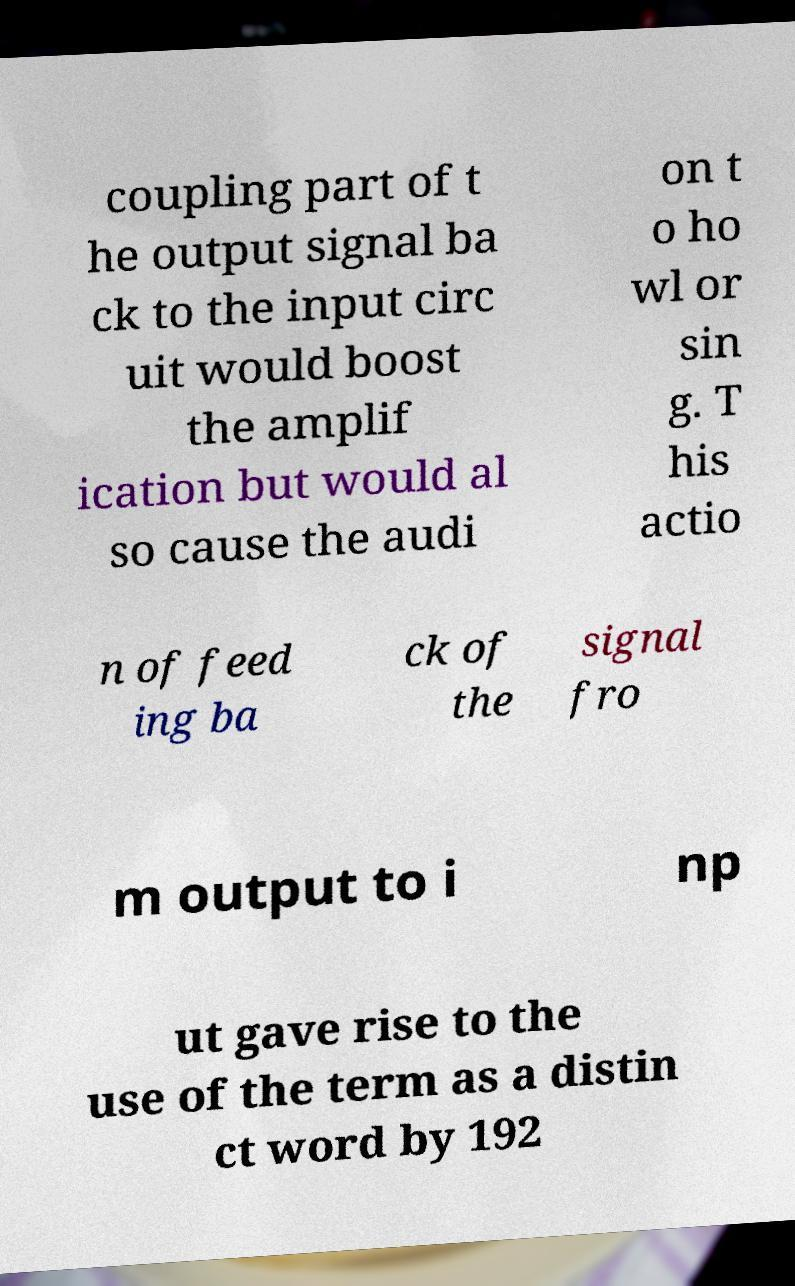Can you read and provide the text displayed in the image?This photo seems to have some interesting text. Can you extract and type it out for me? coupling part of t he output signal ba ck to the input circ uit would boost the amplif ication but would al so cause the audi on t o ho wl or sin g. T his actio n of feed ing ba ck of the signal fro m output to i np ut gave rise to the use of the term as a distin ct word by 192 